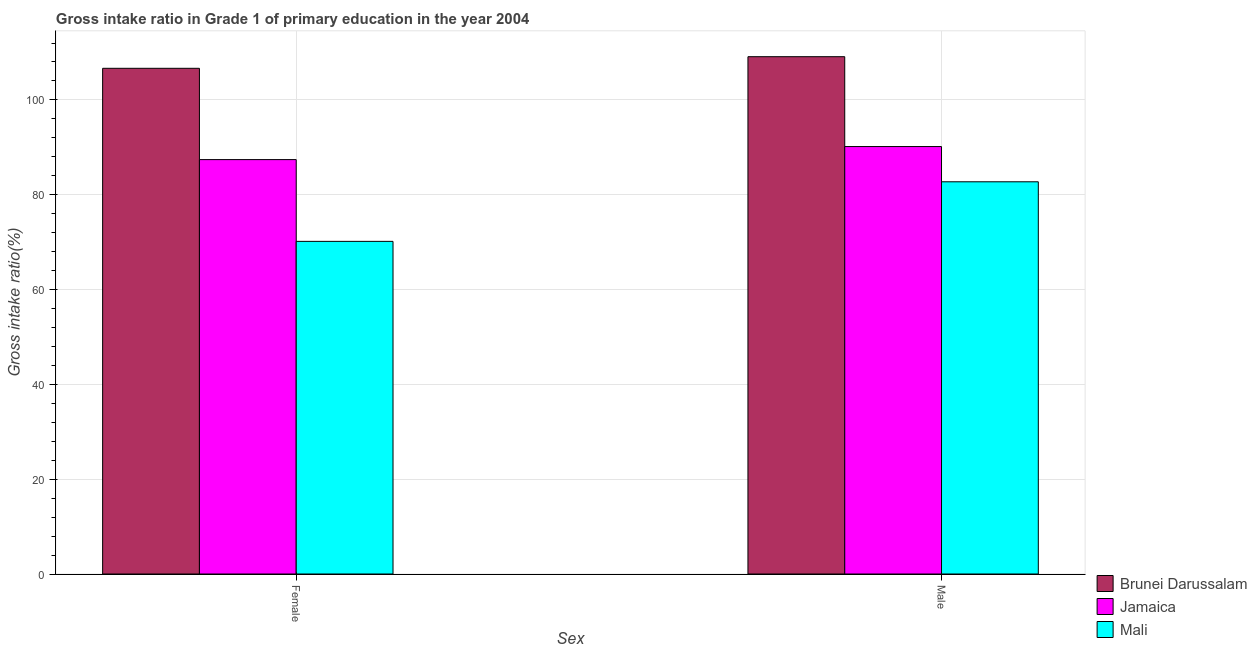Are the number of bars per tick equal to the number of legend labels?
Offer a terse response. Yes. How many bars are there on the 1st tick from the left?
Your answer should be very brief. 3. What is the label of the 2nd group of bars from the left?
Offer a terse response. Male. What is the gross intake ratio(female) in Brunei Darussalam?
Ensure brevity in your answer.  106.66. Across all countries, what is the maximum gross intake ratio(male)?
Your answer should be very brief. 109.11. Across all countries, what is the minimum gross intake ratio(male)?
Your answer should be very brief. 82.73. In which country was the gross intake ratio(male) maximum?
Ensure brevity in your answer.  Brunei Darussalam. In which country was the gross intake ratio(male) minimum?
Offer a very short reply. Mali. What is the total gross intake ratio(male) in the graph?
Your answer should be very brief. 282. What is the difference between the gross intake ratio(male) in Brunei Darussalam and that in Mali?
Offer a terse response. 26.39. What is the difference between the gross intake ratio(female) in Mali and the gross intake ratio(male) in Jamaica?
Your answer should be very brief. -20. What is the average gross intake ratio(male) per country?
Provide a succinct answer. 94. What is the difference between the gross intake ratio(female) and gross intake ratio(male) in Jamaica?
Ensure brevity in your answer.  -2.75. In how many countries, is the gross intake ratio(male) greater than 64 %?
Provide a succinct answer. 3. What is the ratio of the gross intake ratio(male) in Jamaica to that in Brunei Darussalam?
Provide a short and direct response. 0.83. What does the 1st bar from the left in Male represents?
Your answer should be very brief. Brunei Darussalam. What does the 1st bar from the right in Male represents?
Your answer should be very brief. Mali. How many bars are there?
Provide a short and direct response. 6. Are the values on the major ticks of Y-axis written in scientific E-notation?
Keep it short and to the point. No. Does the graph contain grids?
Your answer should be very brief. Yes. Where does the legend appear in the graph?
Keep it short and to the point. Bottom right. What is the title of the graph?
Your answer should be very brief. Gross intake ratio in Grade 1 of primary education in the year 2004. Does "Arab World" appear as one of the legend labels in the graph?
Make the answer very short. No. What is the label or title of the X-axis?
Your response must be concise. Sex. What is the label or title of the Y-axis?
Keep it short and to the point. Gross intake ratio(%). What is the Gross intake ratio(%) in Brunei Darussalam in Female?
Offer a very short reply. 106.66. What is the Gross intake ratio(%) in Jamaica in Female?
Your response must be concise. 87.41. What is the Gross intake ratio(%) of Mali in Female?
Your response must be concise. 70.16. What is the Gross intake ratio(%) in Brunei Darussalam in Male?
Make the answer very short. 109.11. What is the Gross intake ratio(%) in Jamaica in Male?
Make the answer very short. 90.16. What is the Gross intake ratio(%) of Mali in Male?
Your response must be concise. 82.73. Across all Sex, what is the maximum Gross intake ratio(%) in Brunei Darussalam?
Keep it short and to the point. 109.11. Across all Sex, what is the maximum Gross intake ratio(%) of Jamaica?
Your response must be concise. 90.16. Across all Sex, what is the maximum Gross intake ratio(%) of Mali?
Ensure brevity in your answer.  82.73. Across all Sex, what is the minimum Gross intake ratio(%) in Brunei Darussalam?
Provide a short and direct response. 106.66. Across all Sex, what is the minimum Gross intake ratio(%) in Jamaica?
Provide a succinct answer. 87.41. Across all Sex, what is the minimum Gross intake ratio(%) of Mali?
Offer a terse response. 70.16. What is the total Gross intake ratio(%) in Brunei Darussalam in the graph?
Offer a very short reply. 215.78. What is the total Gross intake ratio(%) of Jamaica in the graph?
Offer a very short reply. 177.57. What is the total Gross intake ratio(%) in Mali in the graph?
Your response must be concise. 152.89. What is the difference between the Gross intake ratio(%) in Brunei Darussalam in Female and that in Male?
Ensure brevity in your answer.  -2.45. What is the difference between the Gross intake ratio(%) in Jamaica in Female and that in Male?
Give a very brief answer. -2.75. What is the difference between the Gross intake ratio(%) in Mali in Female and that in Male?
Make the answer very short. -12.57. What is the difference between the Gross intake ratio(%) in Brunei Darussalam in Female and the Gross intake ratio(%) in Jamaica in Male?
Ensure brevity in your answer.  16.51. What is the difference between the Gross intake ratio(%) in Brunei Darussalam in Female and the Gross intake ratio(%) in Mali in Male?
Your response must be concise. 23.94. What is the difference between the Gross intake ratio(%) in Jamaica in Female and the Gross intake ratio(%) in Mali in Male?
Offer a very short reply. 4.68. What is the average Gross intake ratio(%) in Brunei Darussalam per Sex?
Give a very brief answer. 107.89. What is the average Gross intake ratio(%) in Jamaica per Sex?
Make the answer very short. 88.78. What is the average Gross intake ratio(%) of Mali per Sex?
Make the answer very short. 76.44. What is the difference between the Gross intake ratio(%) in Brunei Darussalam and Gross intake ratio(%) in Jamaica in Female?
Your response must be concise. 19.26. What is the difference between the Gross intake ratio(%) in Brunei Darussalam and Gross intake ratio(%) in Mali in Female?
Make the answer very short. 36.5. What is the difference between the Gross intake ratio(%) of Jamaica and Gross intake ratio(%) of Mali in Female?
Keep it short and to the point. 17.25. What is the difference between the Gross intake ratio(%) in Brunei Darussalam and Gross intake ratio(%) in Jamaica in Male?
Offer a terse response. 18.96. What is the difference between the Gross intake ratio(%) in Brunei Darussalam and Gross intake ratio(%) in Mali in Male?
Offer a very short reply. 26.39. What is the difference between the Gross intake ratio(%) of Jamaica and Gross intake ratio(%) of Mali in Male?
Your answer should be very brief. 7.43. What is the ratio of the Gross intake ratio(%) of Brunei Darussalam in Female to that in Male?
Your response must be concise. 0.98. What is the ratio of the Gross intake ratio(%) of Jamaica in Female to that in Male?
Your answer should be very brief. 0.97. What is the ratio of the Gross intake ratio(%) in Mali in Female to that in Male?
Offer a terse response. 0.85. What is the difference between the highest and the second highest Gross intake ratio(%) of Brunei Darussalam?
Offer a very short reply. 2.45. What is the difference between the highest and the second highest Gross intake ratio(%) in Jamaica?
Provide a succinct answer. 2.75. What is the difference between the highest and the second highest Gross intake ratio(%) in Mali?
Offer a terse response. 12.57. What is the difference between the highest and the lowest Gross intake ratio(%) of Brunei Darussalam?
Offer a terse response. 2.45. What is the difference between the highest and the lowest Gross intake ratio(%) of Jamaica?
Keep it short and to the point. 2.75. What is the difference between the highest and the lowest Gross intake ratio(%) in Mali?
Your answer should be compact. 12.57. 